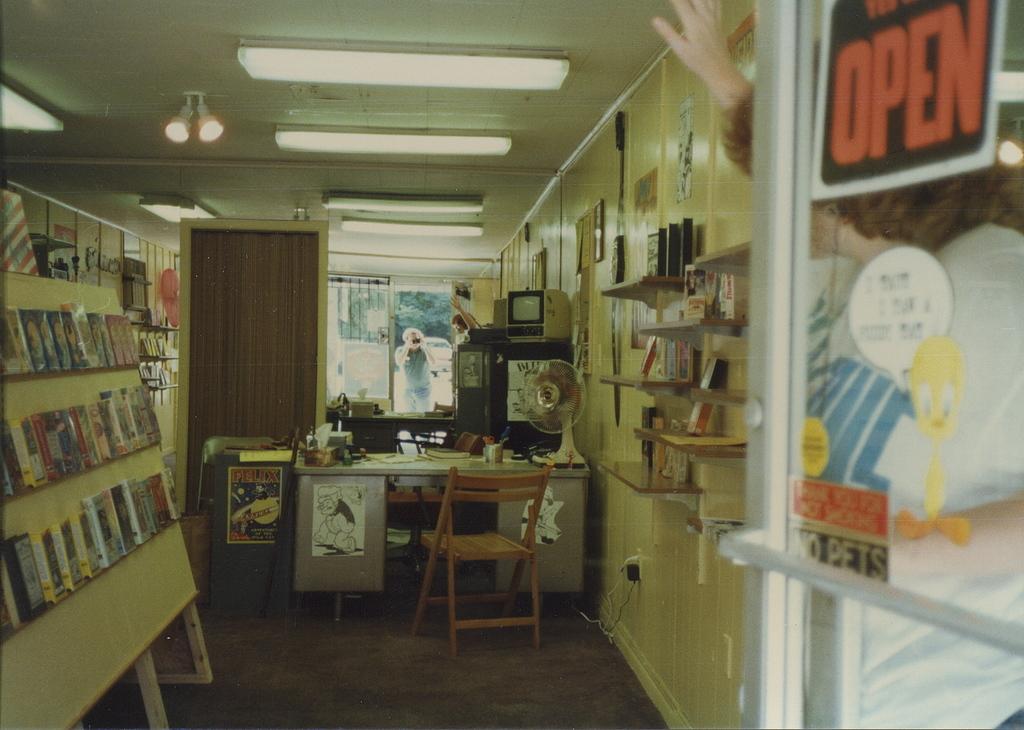Are pets allowed in the store?
Offer a terse response. No. What does the sign say on the top right corner?
Your answer should be compact. Open. 